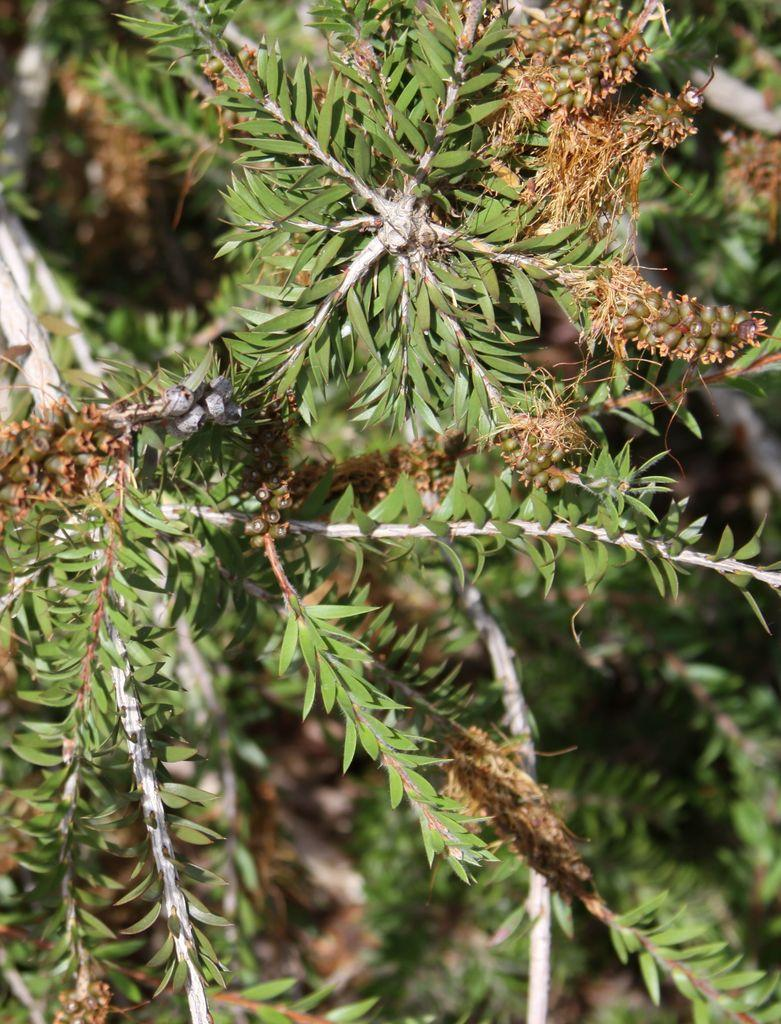What is present in the image? There is a tree in the image. What is special about the tree? The tree has fruits on it. What type of ink can be seen dripping from the tree in the image? There is no ink present in the image; it only features a tree with fruits on it. 